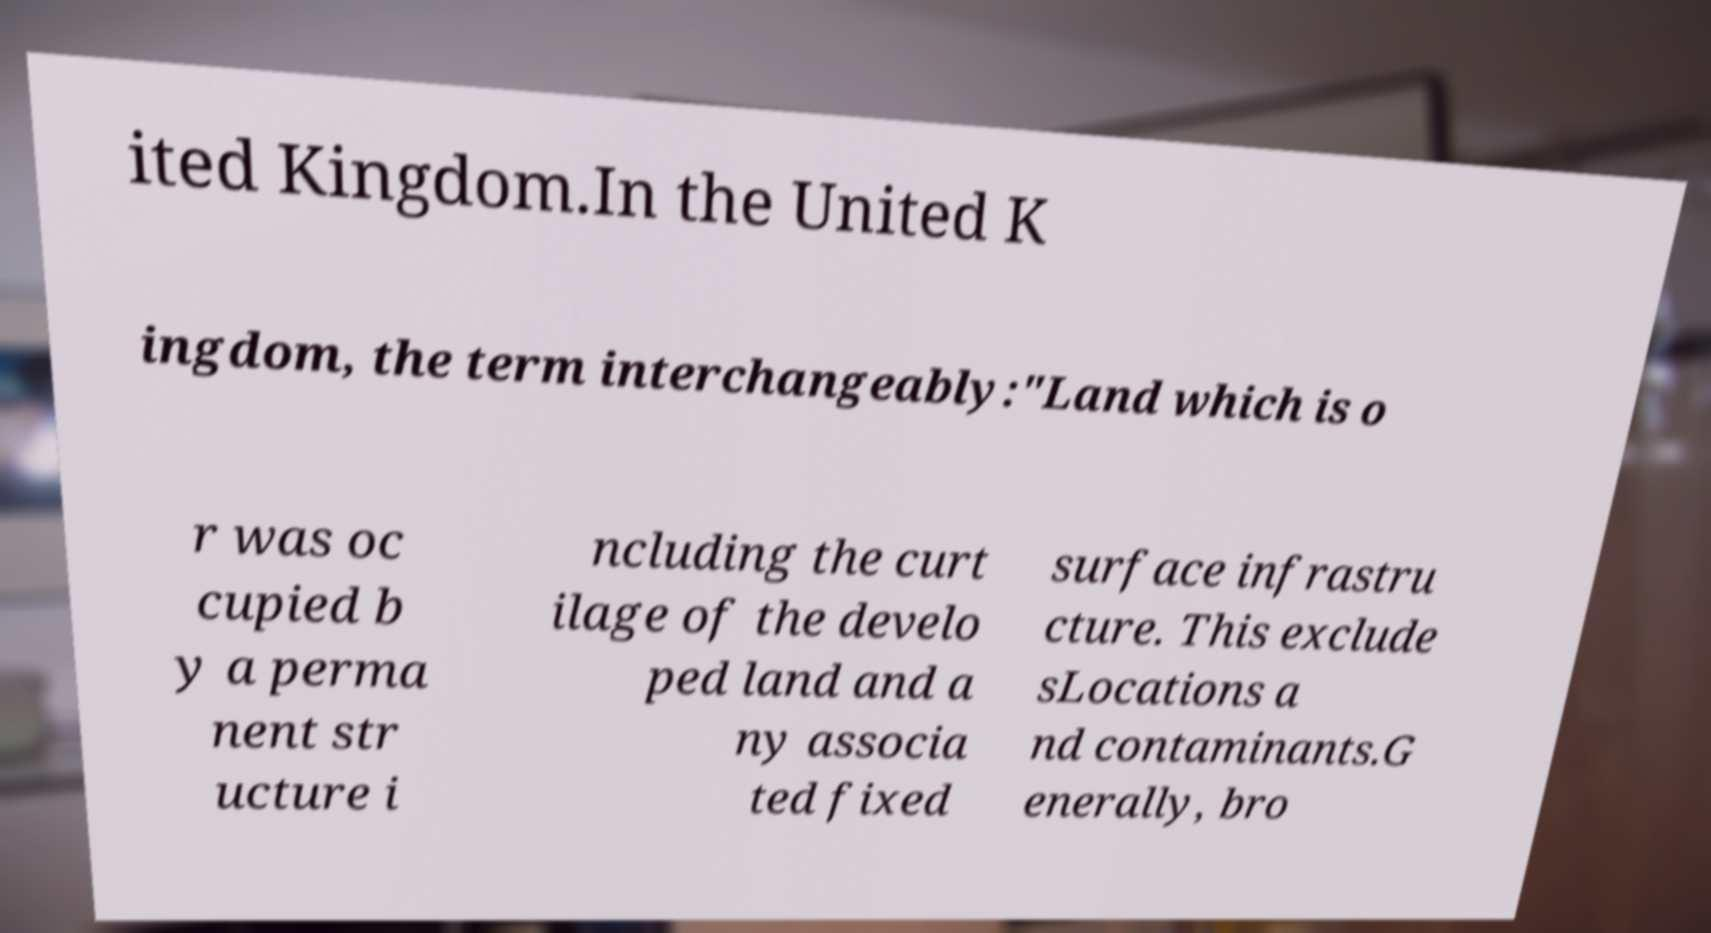Could you assist in decoding the text presented in this image and type it out clearly? ited Kingdom.In the United K ingdom, the term interchangeably:"Land which is o r was oc cupied b y a perma nent str ucture i ncluding the curt ilage of the develo ped land and a ny associa ted fixed surface infrastru cture. This exclude sLocations a nd contaminants.G enerally, bro 